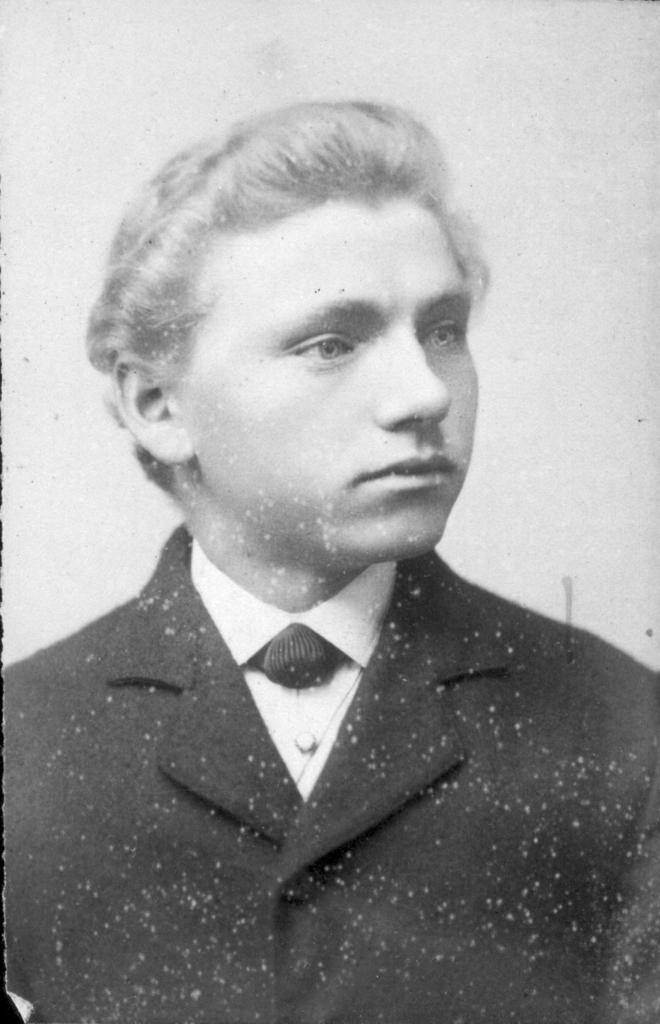What is the main subject of the image? The main subject of the image is an old photo. What can be seen in the old photo? The old photo contains a man. What is the man wearing in the old photo? The man is wearing a suit in the old photo. What can be seen in the background of the old photo? There is a wall visible in the background of the old photo. How many tomatoes are on the wall in the image? There are no tomatoes present in the image; the wall is visible in the background of the old photo, but no tomatoes are depicted. 